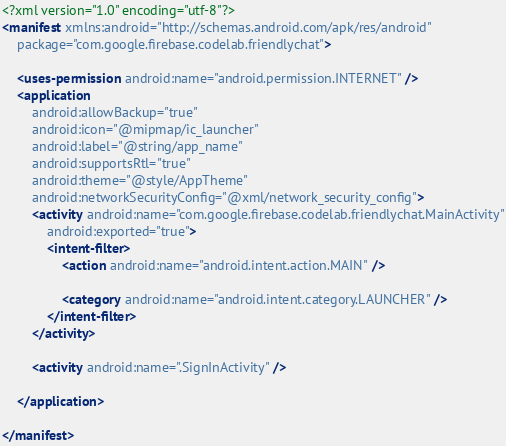<code> <loc_0><loc_0><loc_500><loc_500><_XML_><?xml version="1.0" encoding="utf-8"?>
<manifest xmlns:android="http://schemas.android.com/apk/res/android"
    package="com.google.firebase.codelab.friendlychat">

    <uses-permission android:name="android.permission.INTERNET" />
    <application
        android:allowBackup="true"
        android:icon="@mipmap/ic_launcher"
        android:label="@string/app_name"
        android:supportsRtl="true"
        android:theme="@style/AppTheme"
        android:networkSecurityConfig="@xml/network_security_config">
        <activity android:name="com.google.firebase.codelab.friendlychat.MainActivity"
            android:exported="true">
            <intent-filter>
                <action android:name="android.intent.action.MAIN" />

                <category android:name="android.intent.category.LAUNCHER" />
            </intent-filter>
        </activity>

        <activity android:name=".SignInActivity" />

    </application>

</manifest>
</code> 